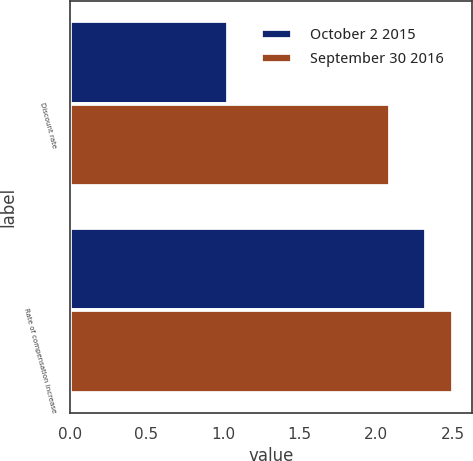Convert chart to OTSL. <chart><loc_0><loc_0><loc_500><loc_500><stacked_bar_chart><ecel><fcel>Discount rate<fcel>Rate of compensation increase<nl><fcel>October 2 2015<fcel>1.03<fcel>2.33<nl><fcel>September 30 2016<fcel>2.09<fcel>2.5<nl></chart> 